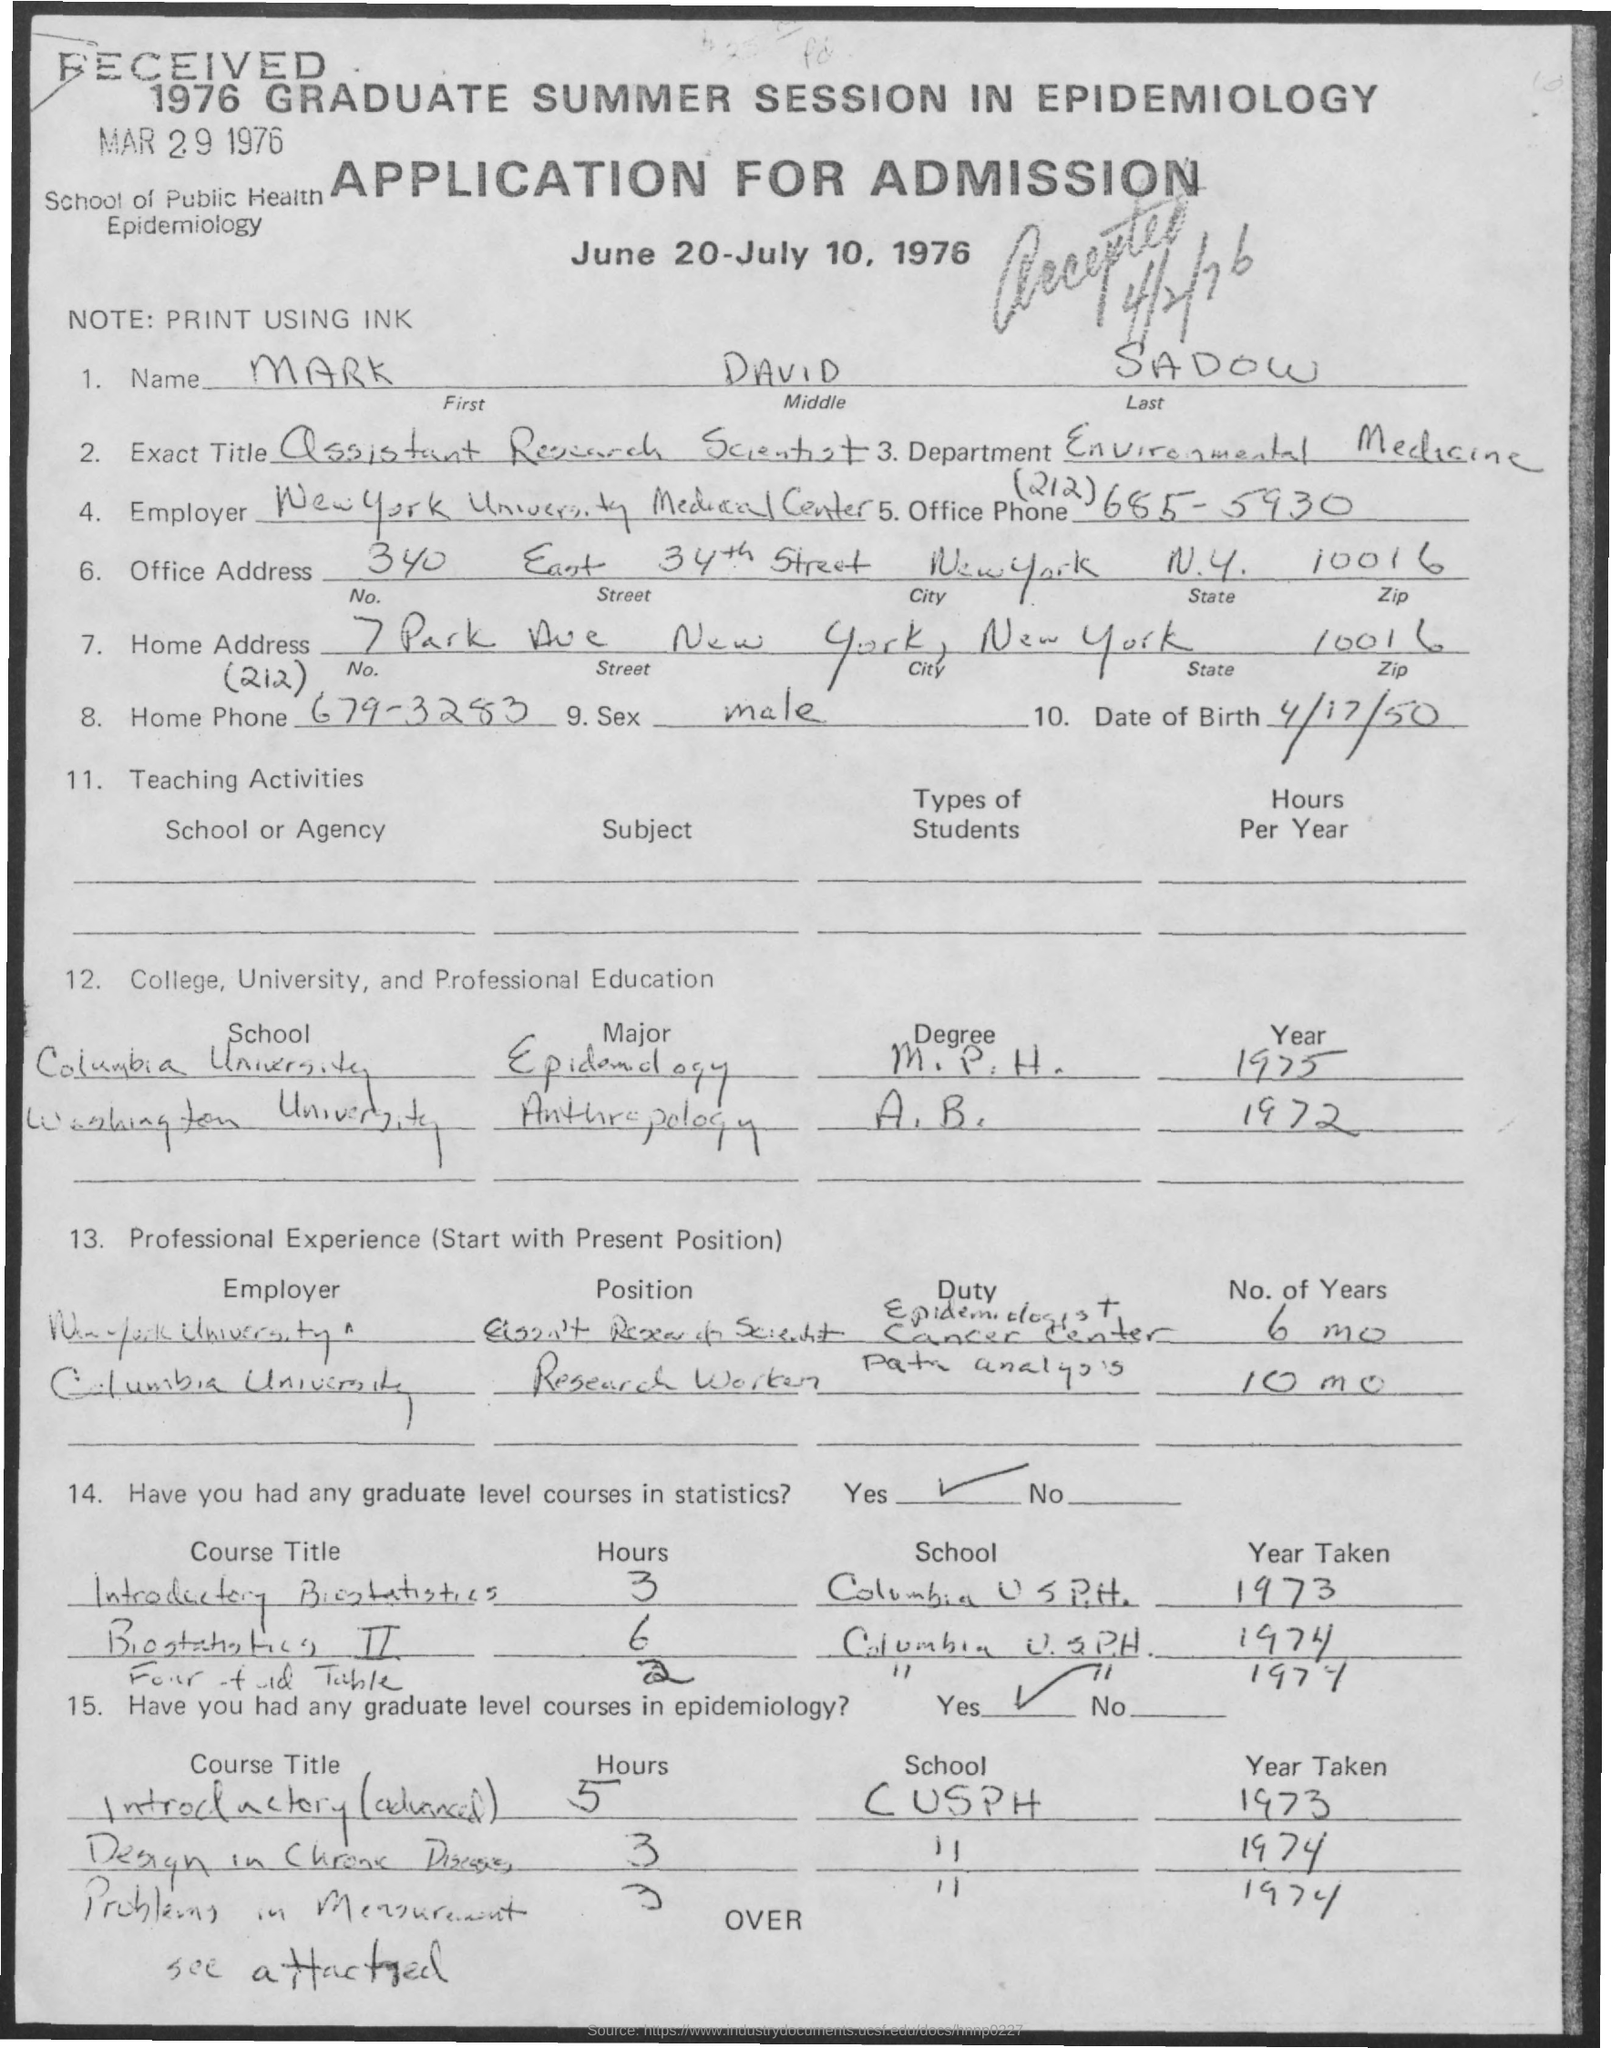Which  Name written in the Memorandum ?
Offer a very short reply. MARK DAVID SADOW. What is the Date of birth of Mark ?
Your answer should be very brief. 4/17/50. 